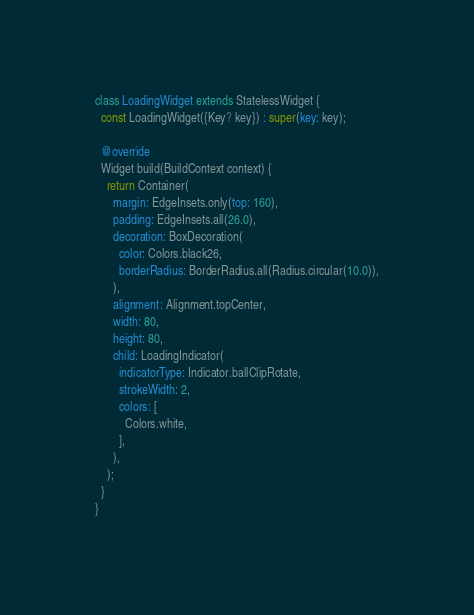Convert code to text. <code><loc_0><loc_0><loc_500><loc_500><_Dart_>
class LoadingWidget extends StatelessWidget {
  const LoadingWidget({Key? key}) : super(key: key);

  @override
  Widget build(BuildContext context) {
    return Container(
      margin: EdgeInsets.only(top: 160),
      padding: EdgeInsets.all(26.0),
      decoration: BoxDecoration(
        color: Colors.black26,
        borderRadius: BorderRadius.all(Radius.circular(10.0)),
      ),
      alignment: Alignment.topCenter,
      width: 80,
      height: 80,
      child: LoadingIndicator(
        indicatorType: Indicator.ballClipRotate,
        strokeWidth: 2,
        colors: [
          Colors.white,
        ],
      ),
    );
  }
}
</code> 